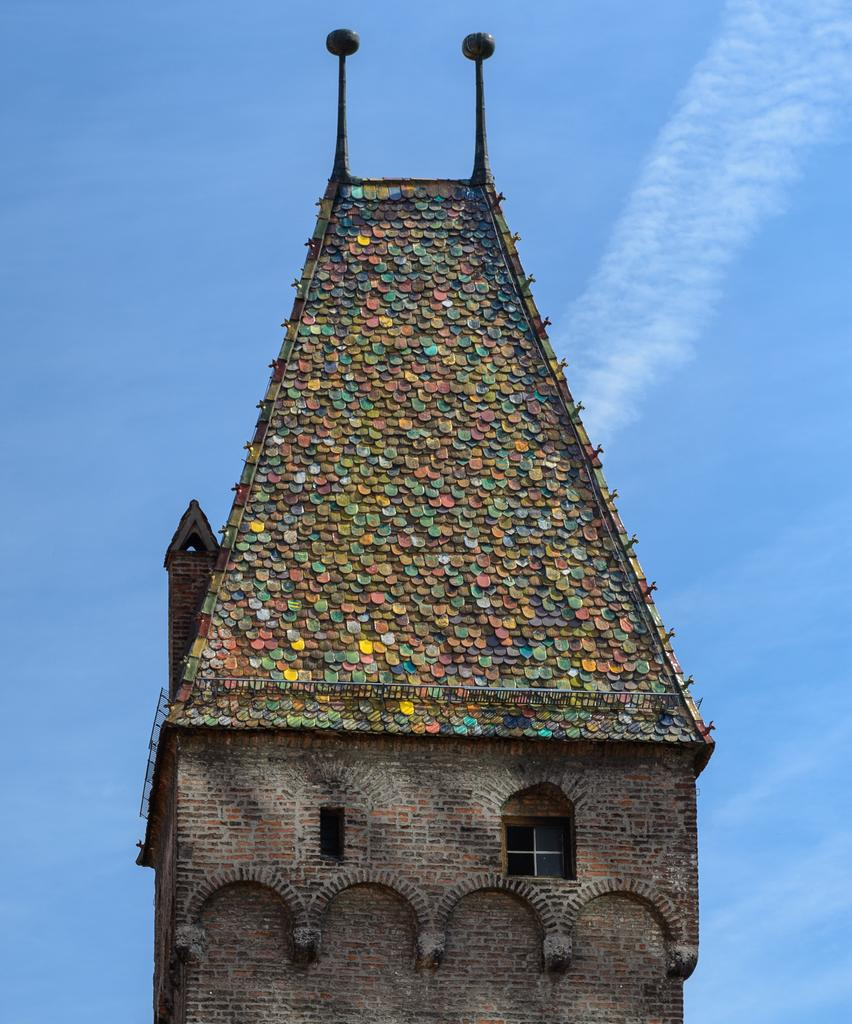What is the main subject in the center of the image? There is a building in the center of the image. What can be seen in the background of the image? The sky is visible in the background of the image. Where is the zoo located in the image? There is no zoo present in the image; it only features a building and the sky. What type of wire is being used to hold the building together in the image? There is no wire visible in the image; it only features a building and the sky. 